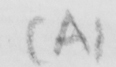Transcribe the text shown in this historical manuscript line. ( A ) 